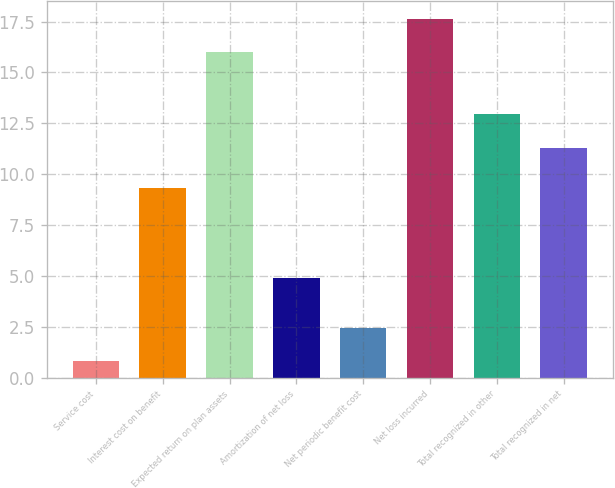Convert chart. <chart><loc_0><loc_0><loc_500><loc_500><bar_chart><fcel>Service cost<fcel>Interest cost on benefit<fcel>Expected return on plan assets<fcel>Amortization of net loss<fcel>Net periodic benefit cost<fcel>Net loss incurred<fcel>Total recognized in other<fcel>Total recognized in net<nl><fcel>0.8<fcel>9.3<fcel>16<fcel>4.9<fcel>2.44<fcel>17.64<fcel>12.94<fcel>11.3<nl></chart> 